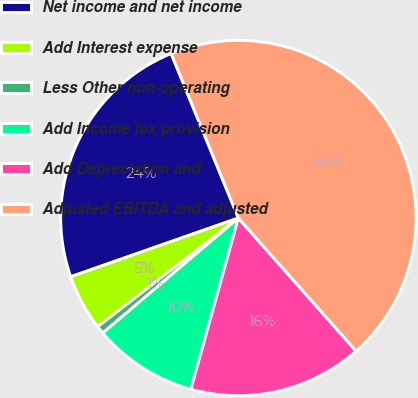Convert chart to OTSL. <chart><loc_0><loc_0><loc_500><loc_500><pie_chart><fcel>Net income and net income<fcel>Add Interest expense<fcel>Less Other non-operating<fcel>Add Income tax provision<fcel>Add Depreciation and<fcel>Adjusted EBITDA and adjusted<nl><fcel>24.19%<fcel>5.11%<fcel>0.72%<fcel>9.5%<fcel>15.84%<fcel>44.64%<nl></chart> 